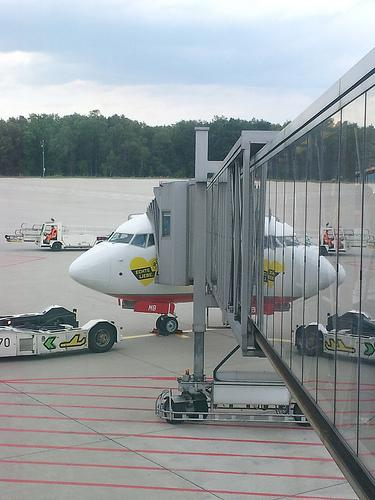What is the relation between the white car and the plane in the image? The white car is parked near the airplane on the tarmac at the airport. Identify the color and type of clothes the man in the image is wearing. The man is wearing orange clothes. How many cloud clusters are there in the image, and are they all the same color? There are nine cloud clusters in the image, and they are all white. What is the main vehicle in the image and its general state? The main vehicle is an airplane in an airport, and it appears to be in good condition. What prominent color is visible throughout the image? White is a prominent color, appearing on the plane, car, clouds, and several objects. Describe the trees in the background of the image. There are many green trees in the distance behind the airport. Can you describe the scene happening around the plane in the image? A plane is parked at an airport, with a loading bridge attached to it. Nearby, a man is driving a truck, and a white car is parked on the tarmac. There are red lines painted on the tarmac, and green trees can be seen in the distance. List all the objects you can identify in the image. Plane, white clouds, blue sky, airplane cockpit windows, airplane nose, front wheel of plane, loading bridge, white car, man driving a truck, man wearing orange clothes, reflection of plane and car on bridge, tarmac red lines, wheel of a vehicle, white vehicle, green trees, overcast sky, passageway to plane, airplane wheels, airport windows, transporter wheels. Mention any patterns or designs present on the airplane. There is a design visible on the airplane. What color is the sky and what type of weather can you infer from the image? The sky is blue with white clouds, and it appears to be overcast. Identify the flock of birds flying next to the white clouds in the blue sky. Although there are white clouds mentioned in the image, there is no mention of any birds. Adding a flock of birds is an assumption not based on the given information. Which image elements could indicate an overcast sky? The sky appears to be overcast, X:1 Y:2 Width:371 Height:371 What type of vehicle is on the tarmac? A white vehicle on the tarmac, X:36 Y:215 Width:65 Height:65 Is there a black motorcycle parked beside the white car near the plane? There is no mention of a motorcycle in the information given. By asking the question about a nonexistent object, the instruction is misleading. Describe the position of a person wearing orange. A person is wearing orange, X:41 Y:222 Width:17 Height:17 Are there any clouds outside the plane at the airport? Yes, there are white clouds in the blue sky. Can you find the pink umbrella floating above the plane? There is no mention of a pink umbrella in the image information provided, and it is an unlikely object to be seen at an airport scene. How many green trees can be seen behind the airport? Green trees behind the airport, X:7 Y:111 Width:245 Height:245 On the right side of the image, notice a group of people holding colorful balloons near the green trees. The image information does not mention any people or balloons. This instruction incorporates nonexistent objects (people and balloons) and falsely associates them with existing elements (the green trees). What emotions can be associated with the image's elements? calmness (sky), excitement (plane), tranquility (trees) Identify the object that has a design on it. Design on a plane, X:126 Y:254 Width:30 Height:30 Point out the objects that are in the sky. plane, white clouds in blue sky Find the proportionate size of the white car near the plane and the man driving a truck. car: 124x124, man: 86x86 Observe the giant teddy bear sitting on top of the loading bridge of the plane. The image information provided does not mention a giant teddy bear, an unlikely and fantastical element in an airport setting, making it misleading. What are the main attributes of the plane's cockpit window? Windows of the cockpit, X:104 Y:224 Width:53 Height:53 Describe the appearance of the front of the plane. Front of a plane at an airport, X:64 Y:199 Width:107 Height:107 Count the number of green trees in the image and describe their appearance. Many green trees in the distance, X:1 Y:107 Width:371 Height:371 Are there any unusual occurrences or anomalies in the image? No significant anomalies detected Identify and describe the vehicle next to the plane. white car near the plane, X:3 Y:300 Width:124 Height:124 What type of vehicle is near the plane? A truck near a plane, X:2 Y:276 Width:167 Height:167 Describe where the red lines are located in the image. Red lines on the tarmac, X:2 Y:375 Width:354 Height:354 Where are the wheels of the airplane located? Wheels under the airplane, X:148 Y:310 Width:34 Height:34 In the distance, you can see a hot air balloon floating above the green trees. The image information does not include any details about a hot air balloon, and it is not typically associated with an airport scene. Adding the hot air balloon to the instruction is misleading and not based on the given information. What is the color of the plane? The plane is white Identify all the colors of the objects in the image. white, blue, green, orange, black, red, gray 